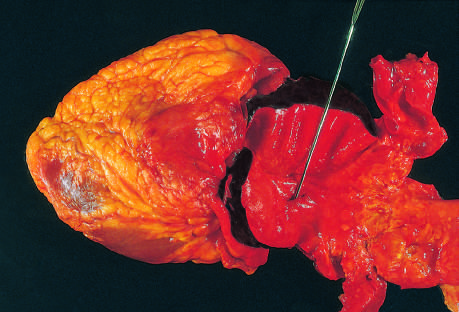does stillbirth lie at the edge of a large area of atherosclerosis, which arrested the propagation of the dissection?
Answer the question using a single word or phrase. No 